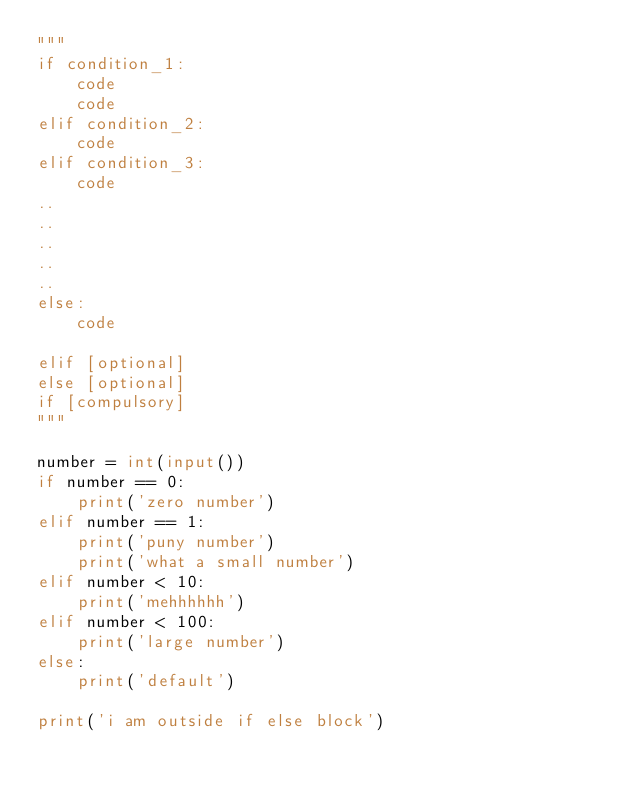Convert code to text. <code><loc_0><loc_0><loc_500><loc_500><_Python_>"""
if condition_1:
    code
    code
elif condition_2:
    code
elif condition_3:
    code
..
..
..
..
..
else:
    code

elif [optional]
else [optional]
if [compulsory]
"""

number = int(input())
if number == 0:
    print('zero number')
elif number == 1:
    print('puny number')
    print('what a small number')
elif number < 10:
    print('mehhhhhh')
elif number < 100:
    print('large number')
else:
    print('default')

print('i am outside if else block')
</code> 